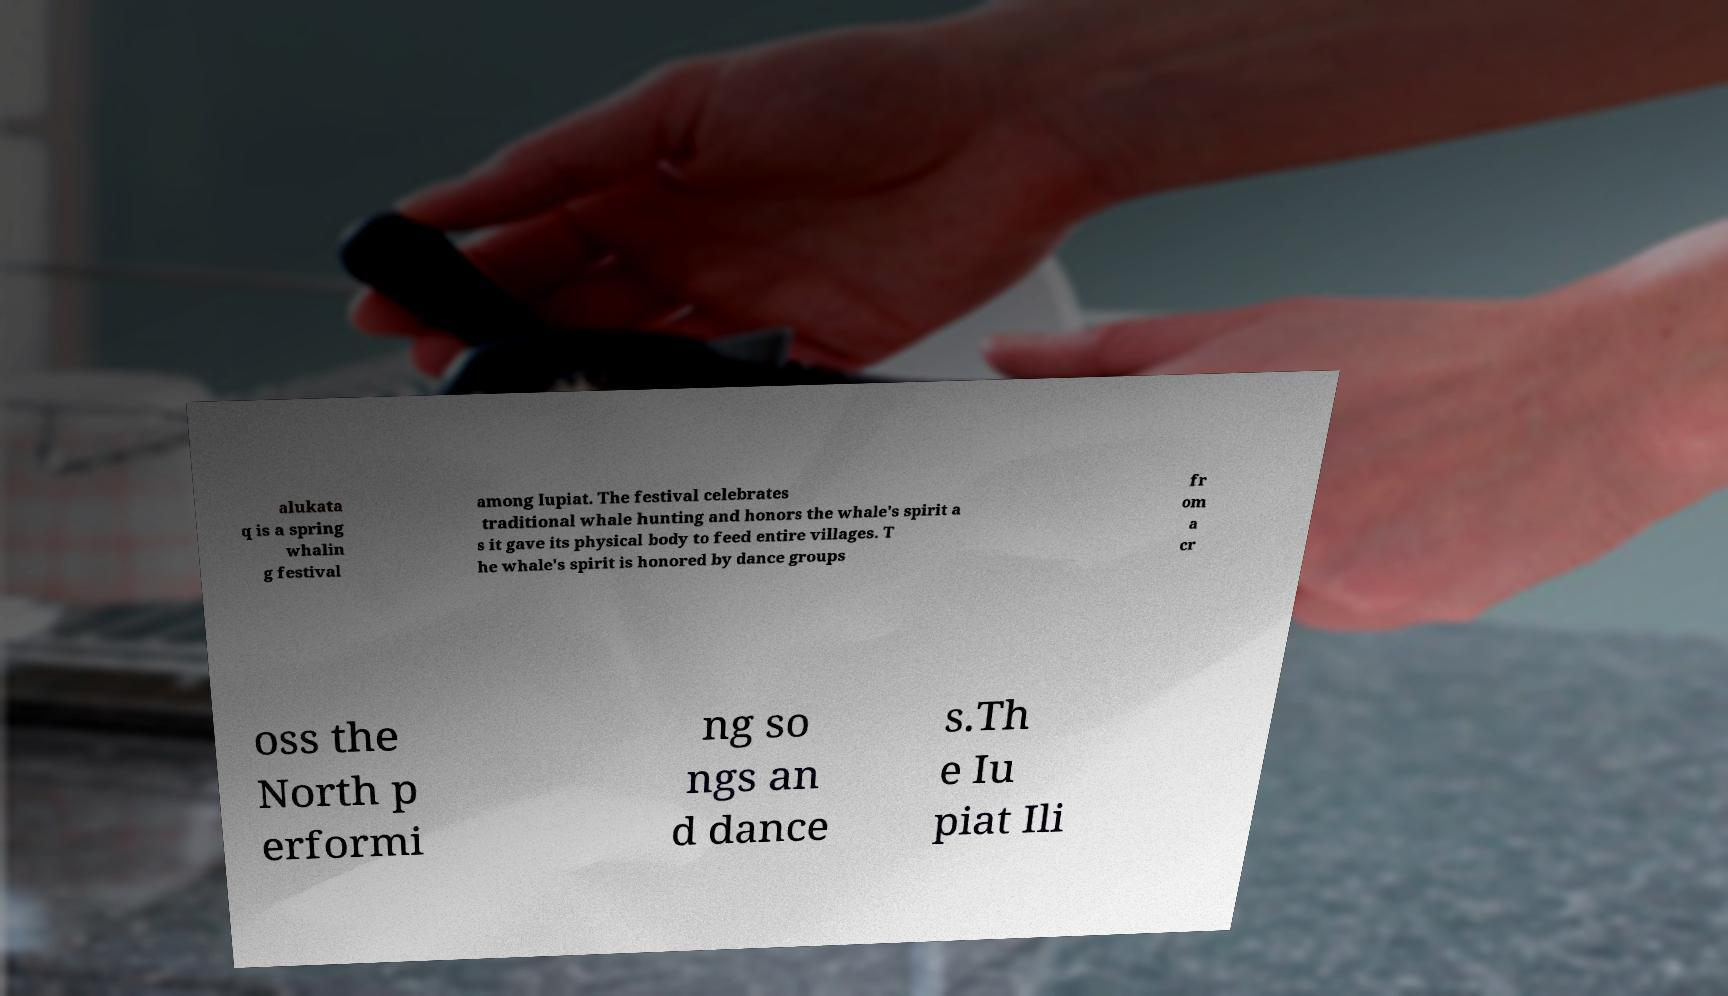Can you accurately transcribe the text from the provided image for me? alukata q is a spring whalin g festival among Iupiat. The festival celebrates traditional whale hunting and honors the whale's spirit a s it gave its physical body to feed entire villages. T he whale's spirit is honored by dance groups fr om a cr oss the North p erformi ng so ngs an d dance s.Th e Iu piat Ili 